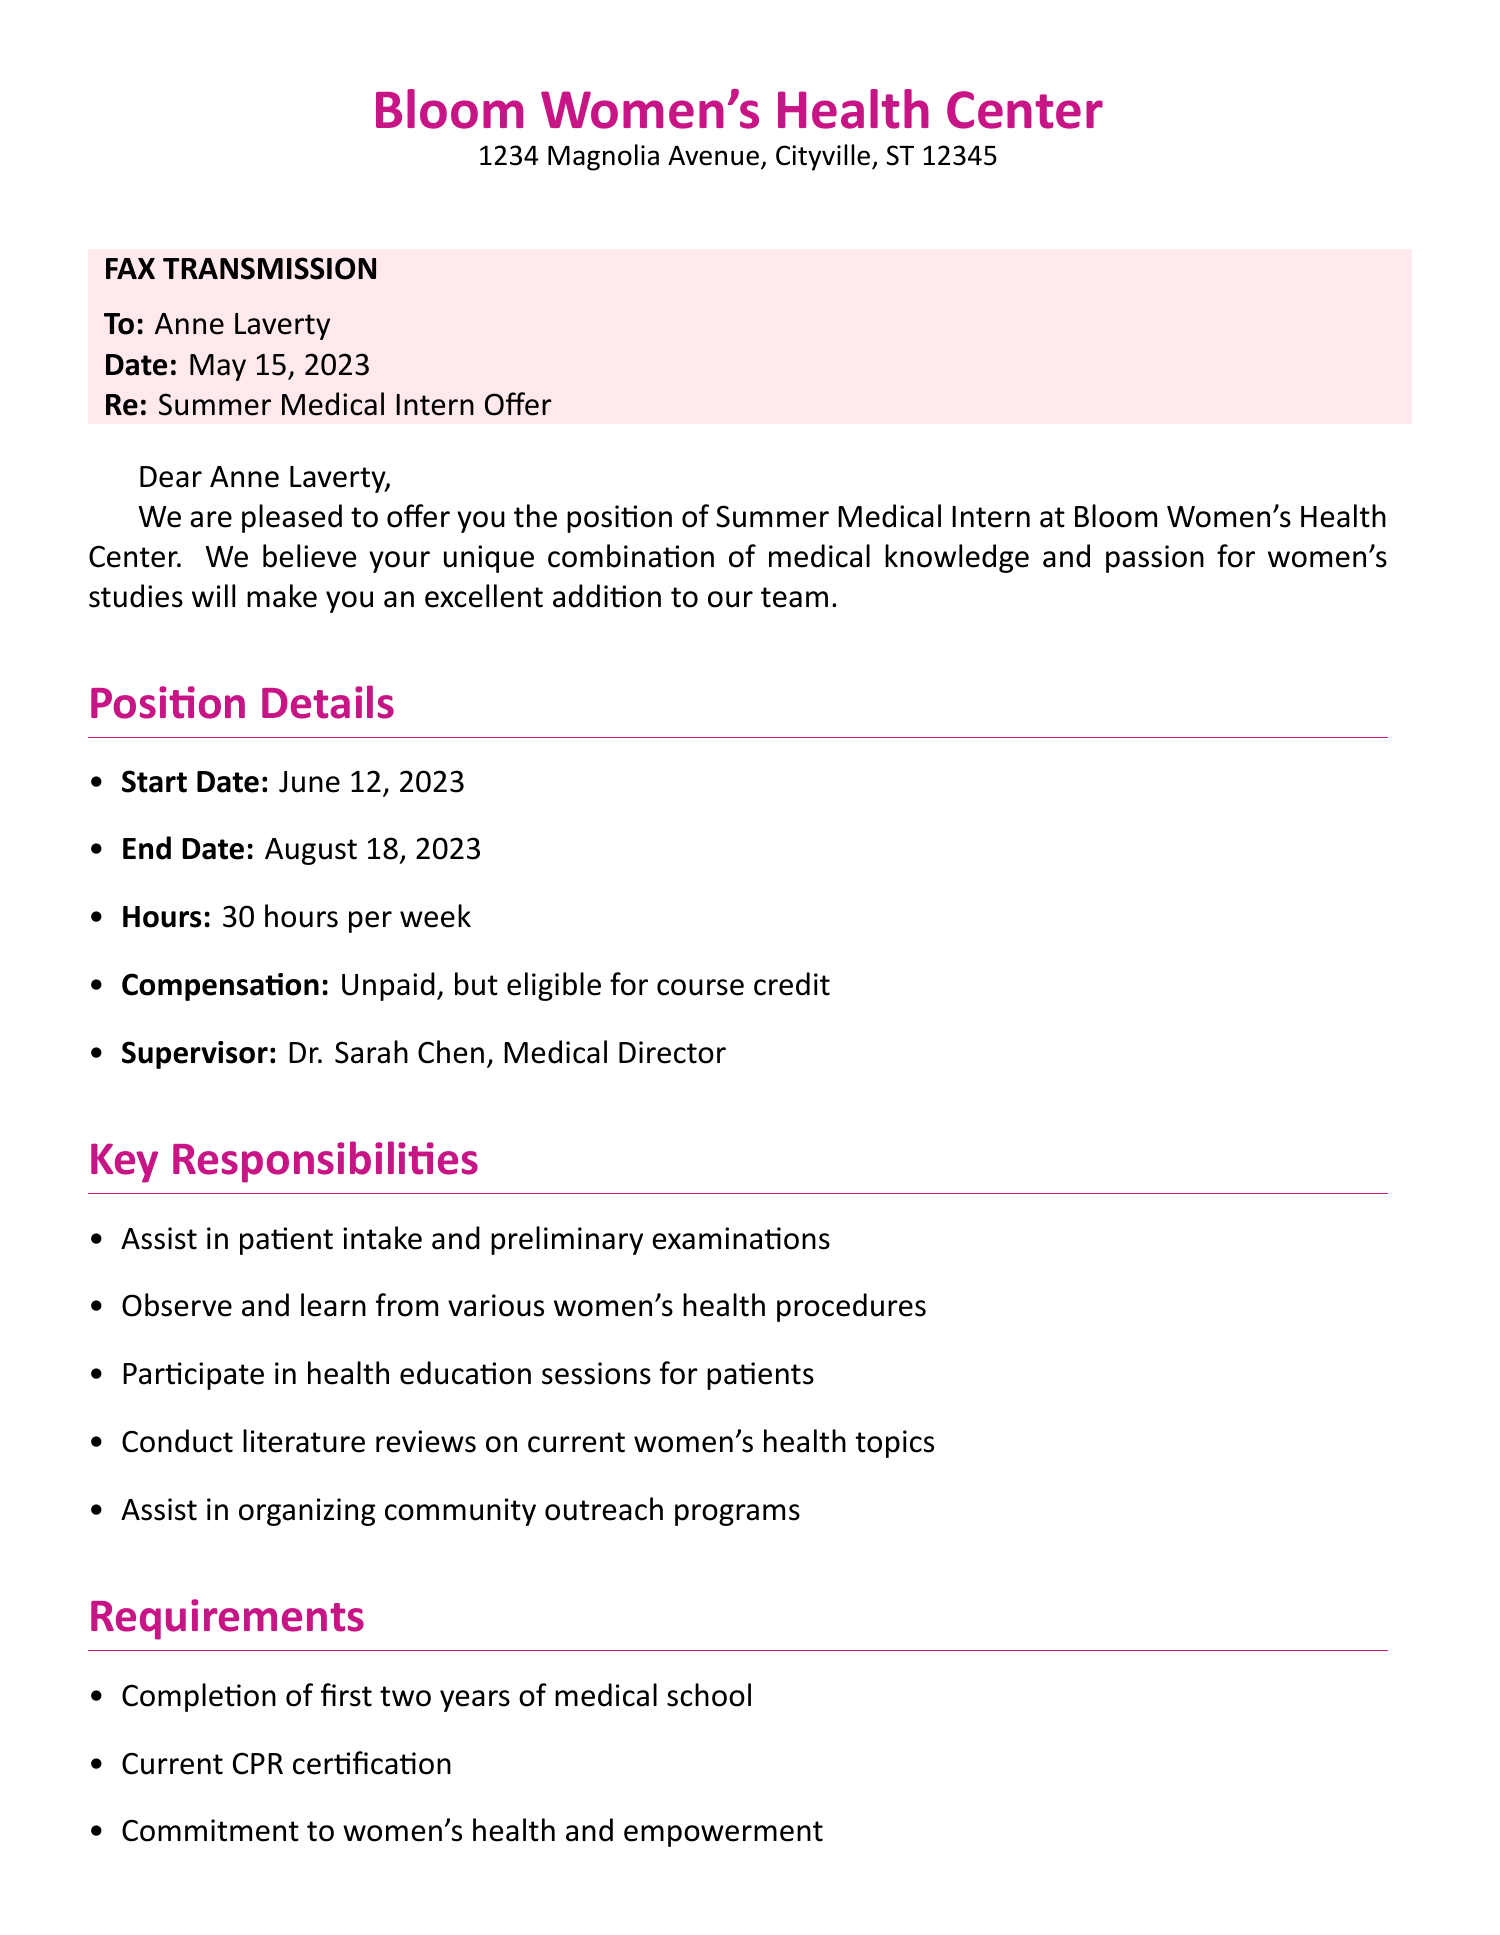What is the name of the clinic? The clinic is referred to as Bloom Women's Health Center in the document.
Answer: Bloom Women's Health Center Who is the supervisor for the internship? The document specifies that the supervisor is Dr. Sarah Chen, the Medical Director.
Answer: Dr. Sarah Chen What is the start date of the internship? The document lists the start date of the internship as June 12, 2023.
Answer: June 12, 2023 How many hours per week is the internship scheduled for? The document states that the internship is for 30 hours per week.
Answer: 30 hours per week Is the internship paid or unpaid? The document clearly indicates that the internship is unpaid.
Answer: Unpaid What is one of the key responsibilities of the intern? The document lists several key responsibilities, including assisting in patient intake and preliminary examinations.
Answer: Assist in patient intake and preliminary examinations What is required for the interns regarding medical school? The document mentions that interns must complete the first two years of medical school.
Answer: Completion of first two years of medical school By when must Anne confirm her acceptance of the offer? The document notes that Anne should confirm her acceptance by May 31, 2023.
Answer: May 31, 2023 What kind of sessions are interns encouraged to participate in? According to the document, interns are encouraged to participate in monthly staff dance socials.
Answer: Monthly staff dance socials 